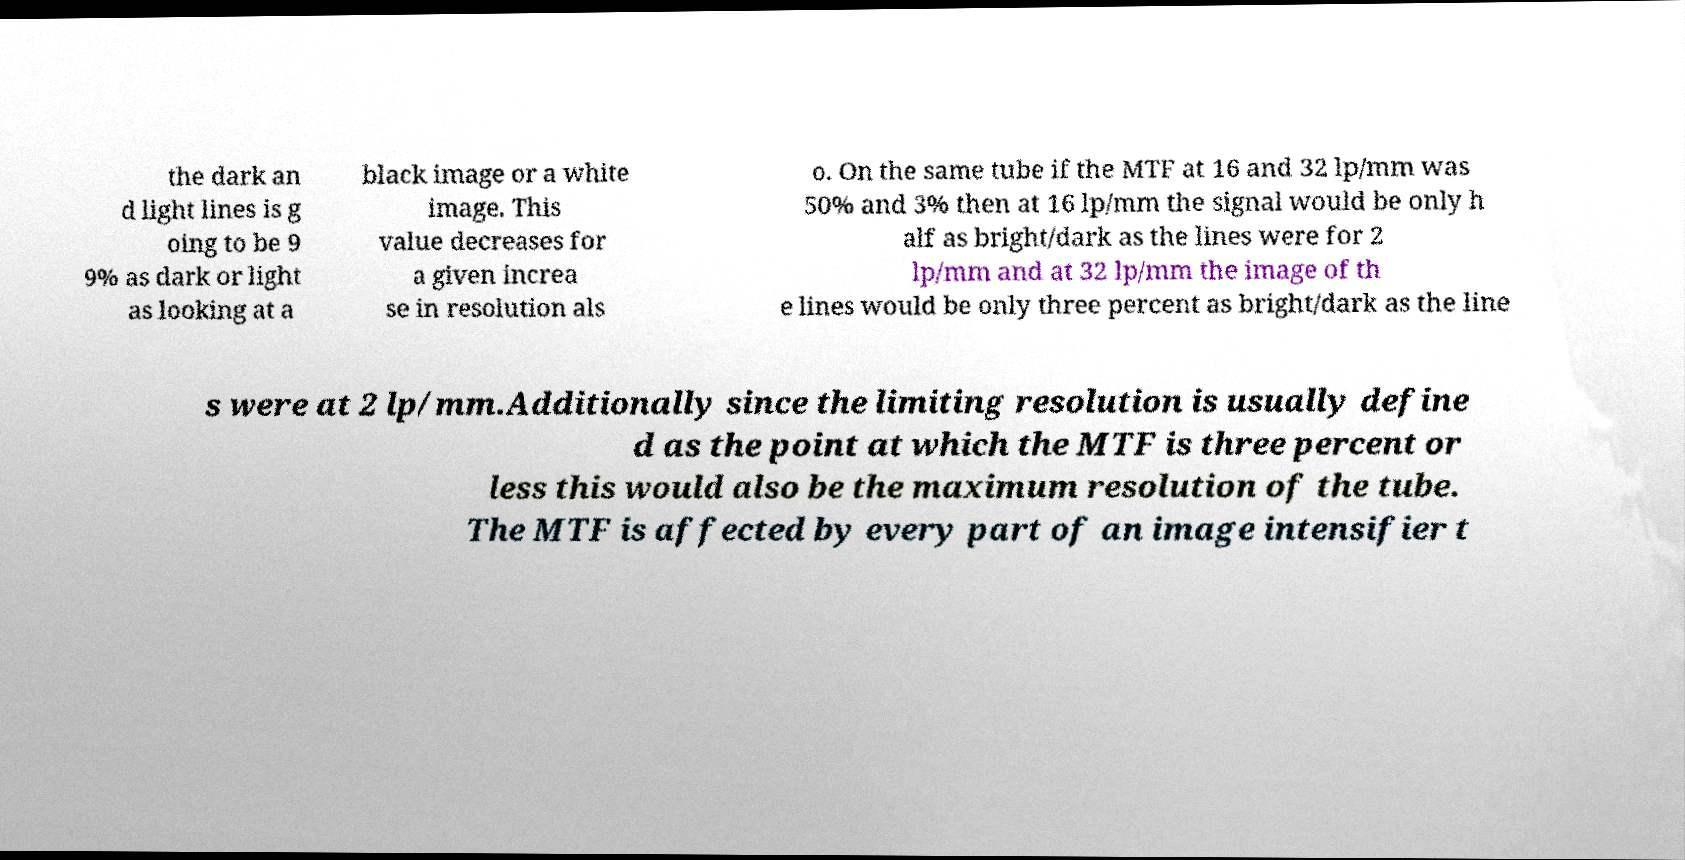Can you accurately transcribe the text from the provided image for me? the dark an d light lines is g oing to be 9 9% as dark or light as looking at a black image or a white image. This value decreases for a given increa se in resolution als o. On the same tube if the MTF at 16 and 32 lp/mm was 50% and 3% then at 16 lp/mm the signal would be only h alf as bright/dark as the lines were for 2 lp/mm and at 32 lp/mm the image of th e lines would be only three percent as bright/dark as the line s were at 2 lp/mm.Additionally since the limiting resolution is usually define d as the point at which the MTF is three percent or less this would also be the maximum resolution of the tube. The MTF is affected by every part of an image intensifier t 